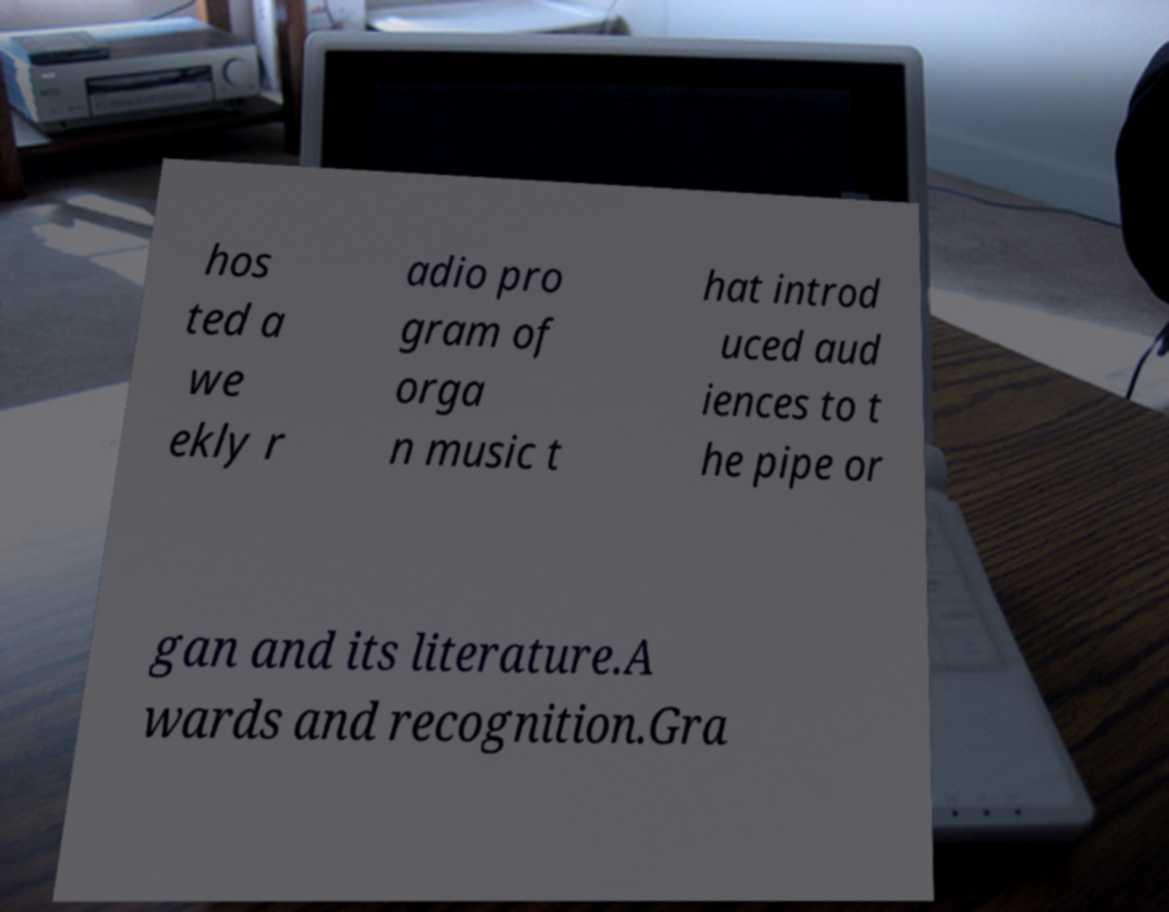What messages or text are displayed in this image? I need them in a readable, typed format. hos ted a we ekly r adio pro gram of orga n music t hat introd uced aud iences to t he pipe or gan and its literature.A wards and recognition.Gra 